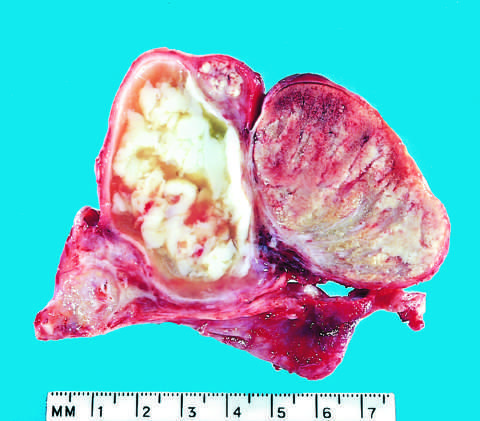s this in turn involved by an abscess?
Answer the question using a single word or phrase. No 